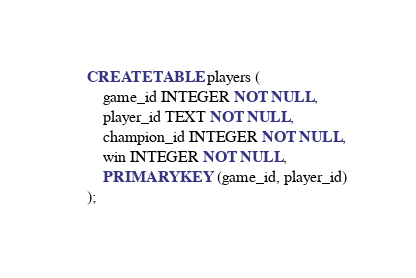Convert code to text. <code><loc_0><loc_0><loc_500><loc_500><_SQL_>
CREATE TABLE players (
	game_id INTEGER NOT NULL,
	player_id TEXT NOT NULL,
	champion_id INTEGER NOT NULL,
	win INTEGER NOT NULL, 
	PRIMARY KEY (game_id, player_id)
);
</code> 